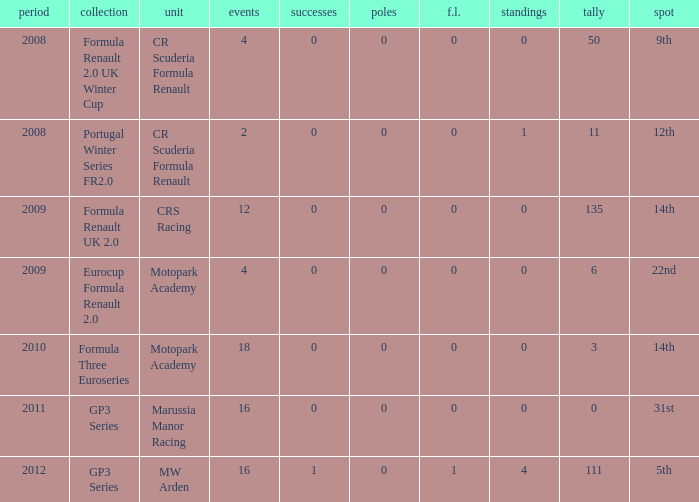What is the least amount of podiums? 0.0. 